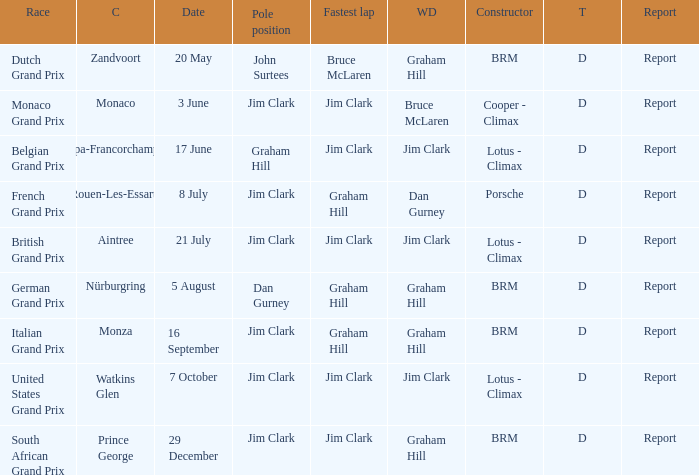Could you parse the entire table? {'header': ['Race', 'C', 'Date', 'Pole position', 'Fastest lap', 'WD', 'Constructor', 'T', 'Report'], 'rows': [['Dutch Grand Prix', 'Zandvoort', '20 May', 'John Surtees', 'Bruce McLaren', 'Graham Hill', 'BRM', 'D', 'Report'], ['Monaco Grand Prix', 'Monaco', '3 June', 'Jim Clark', 'Jim Clark', 'Bruce McLaren', 'Cooper - Climax', 'D', 'Report'], ['Belgian Grand Prix', 'Spa-Francorchamps', '17 June', 'Graham Hill', 'Jim Clark', 'Jim Clark', 'Lotus - Climax', 'D', 'Report'], ['French Grand Prix', 'Rouen-Les-Essarts', '8 July', 'Jim Clark', 'Graham Hill', 'Dan Gurney', 'Porsche', 'D', 'Report'], ['British Grand Prix', 'Aintree', '21 July', 'Jim Clark', 'Jim Clark', 'Jim Clark', 'Lotus - Climax', 'D', 'Report'], ['German Grand Prix', 'Nürburgring', '5 August', 'Dan Gurney', 'Graham Hill', 'Graham Hill', 'BRM', 'D', 'Report'], ['Italian Grand Prix', 'Monza', '16 September', 'Jim Clark', 'Graham Hill', 'Graham Hill', 'BRM', 'D', 'Report'], ['United States Grand Prix', 'Watkins Glen', '7 October', 'Jim Clark', 'Jim Clark', 'Jim Clark', 'Lotus - Climax', 'D', 'Report'], ['South African Grand Prix', 'Prince George', '29 December', 'Jim Clark', 'Jim Clark', 'Graham Hill', 'BRM', 'D', 'Report']]} What is the tyre for the circuit of Prince George, which had Jim Clark as the fastest lap? D. 